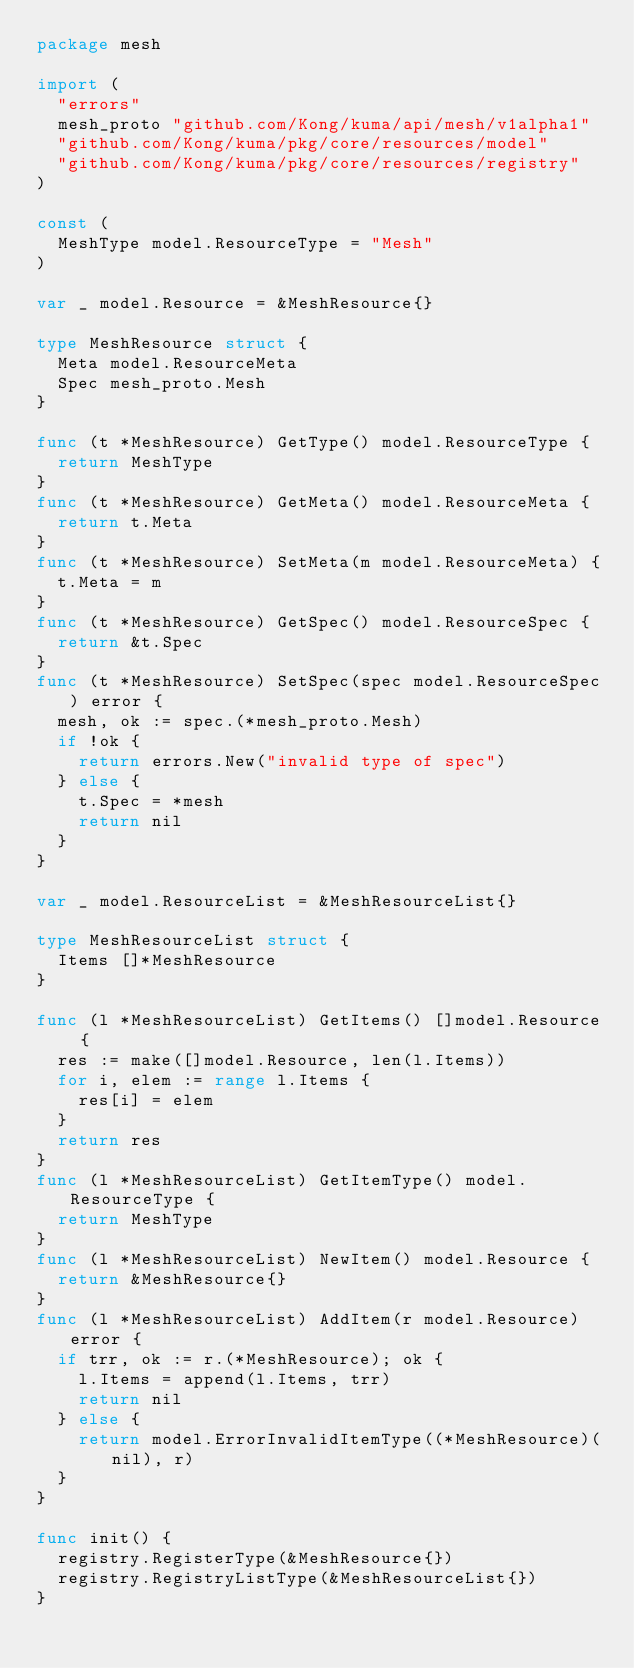<code> <loc_0><loc_0><loc_500><loc_500><_Go_>package mesh

import (
	"errors"
	mesh_proto "github.com/Kong/kuma/api/mesh/v1alpha1"
	"github.com/Kong/kuma/pkg/core/resources/model"
	"github.com/Kong/kuma/pkg/core/resources/registry"
)

const (
	MeshType model.ResourceType = "Mesh"
)

var _ model.Resource = &MeshResource{}

type MeshResource struct {
	Meta model.ResourceMeta
	Spec mesh_proto.Mesh
}

func (t *MeshResource) GetType() model.ResourceType {
	return MeshType
}
func (t *MeshResource) GetMeta() model.ResourceMeta {
	return t.Meta
}
func (t *MeshResource) SetMeta(m model.ResourceMeta) {
	t.Meta = m
}
func (t *MeshResource) GetSpec() model.ResourceSpec {
	return &t.Spec
}
func (t *MeshResource) SetSpec(spec model.ResourceSpec) error {
	mesh, ok := spec.(*mesh_proto.Mesh)
	if !ok {
		return errors.New("invalid type of spec")
	} else {
		t.Spec = *mesh
		return nil
	}
}

var _ model.ResourceList = &MeshResourceList{}

type MeshResourceList struct {
	Items []*MeshResource
}

func (l *MeshResourceList) GetItems() []model.Resource {
	res := make([]model.Resource, len(l.Items))
	for i, elem := range l.Items {
		res[i] = elem
	}
	return res
}
func (l *MeshResourceList) GetItemType() model.ResourceType {
	return MeshType
}
func (l *MeshResourceList) NewItem() model.Resource {
	return &MeshResource{}
}
func (l *MeshResourceList) AddItem(r model.Resource) error {
	if trr, ok := r.(*MeshResource); ok {
		l.Items = append(l.Items, trr)
		return nil
	} else {
		return model.ErrorInvalidItemType((*MeshResource)(nil), r)
	}
}

func init() {
	registry.RegisterType(&MeshResource{})
	registry.RegistryListType(&MeshResourceList{})
}
</code> 